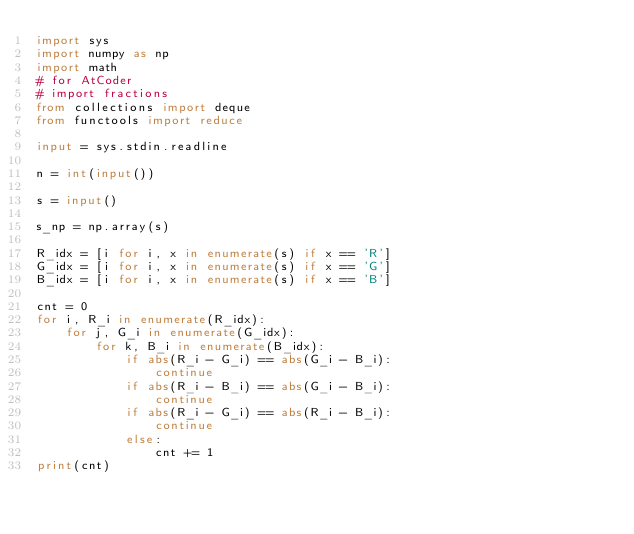Convert code to text. <code><loc_0><loc_0><loc_500><loc_500><_Python_>import sys
import numpy as np
import math
# for AtCoder
# import fractions
from collections import deque 
from functools import reduce

input = sys.stdin.readline

n = int(input())

s = input()

s_np = np.array(s)

R_idx = [i for i, x in enumerate(s) if x == 'R']
G_idx = [i for i, x in enumerate(s) if x == 'G']
B_idx = [i for i, x in enumerate(s) if x == 'B']

cnt = 0
for i, R_i in enumerate(R_idx):
    for j, G_i in enumerate(G_idx):
        for k, B_i in enumerate(B_idx):
            if abs(R_i - G_i) == abs(G_i - B_i):
                continue
            if abs(R_i - B_i) == abs(G_i - B_i):
                continue
            if abs(R_i - G_i) == abs(R_i - B_i):
                continue
            else:
                cnt += 1
print(cnt)</code> 